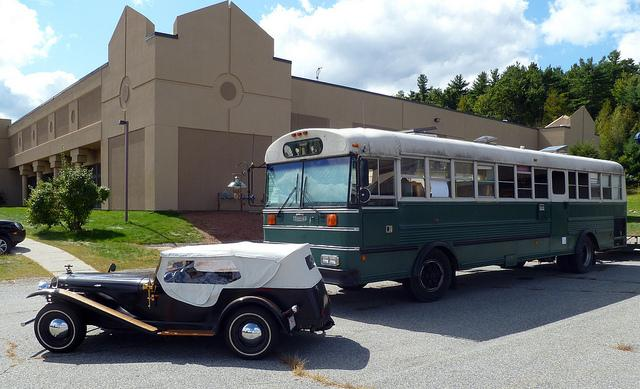Who is in danger of being struc? car 